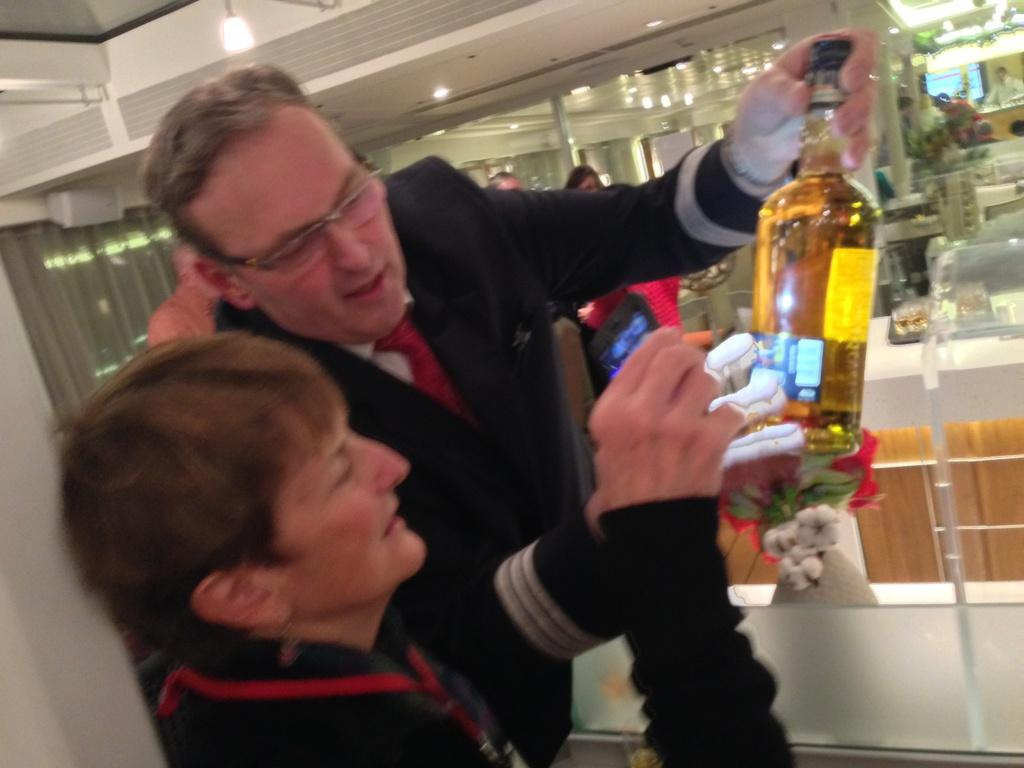How many people are in the image? There are many people in the image. What type of furniture is present in the image? There are tables and chairs in the image. Can you describe the actions of two people in the front of the image? Two people are holding a bottle in the front of the image, one of whom is a woman and the other a man. Where is the light located in the image? There is a light on the top of the image. What type of comfort can be seen in the image? There is no specific comfort item or feature present in the image. What type of drug is being consumed by the people in the image? There is no indication of any drug consumption in the image; the two people are holding a bottle, but its contents are not specified. 